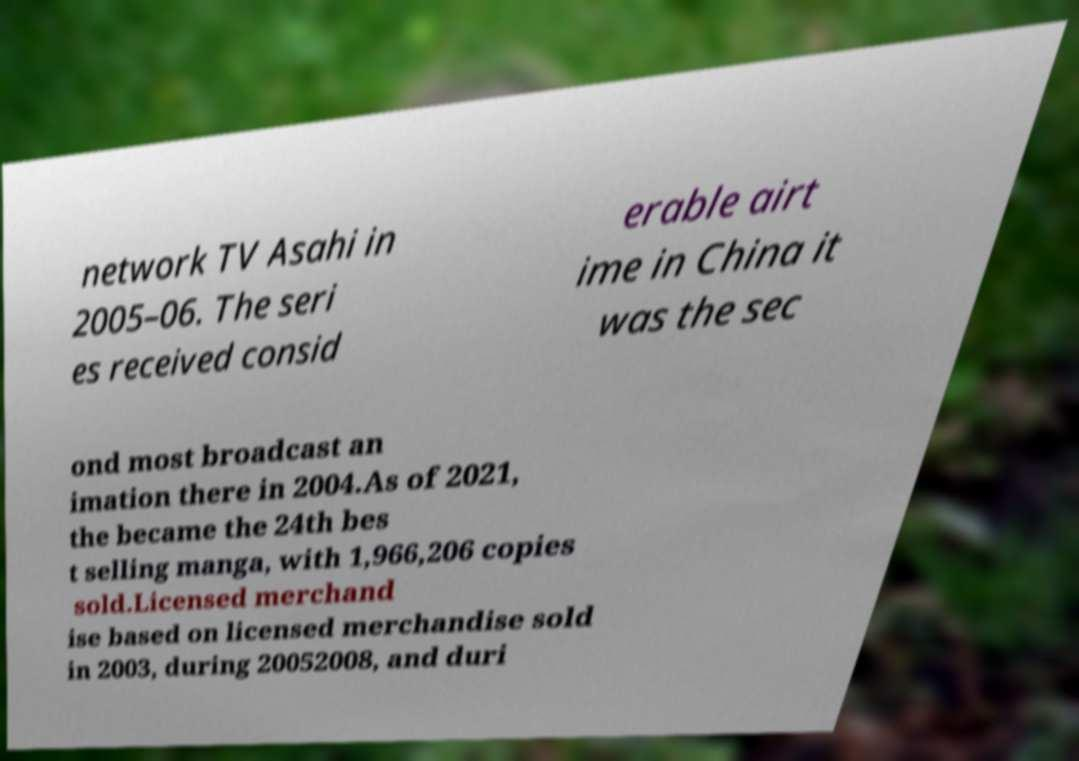Please identify and transcribe the text found in this image. network TV Asahi in 2005–06. The seri es received consid erable airt ime in China it was the sec ond most broadcast an imation there in 2004.As of 2021, the became the 24th bes t selling manga, with 1,966,206 copies sold.Licensed merchand ise based on licensed merchandise sold in 2003, during 20052008, and duri 